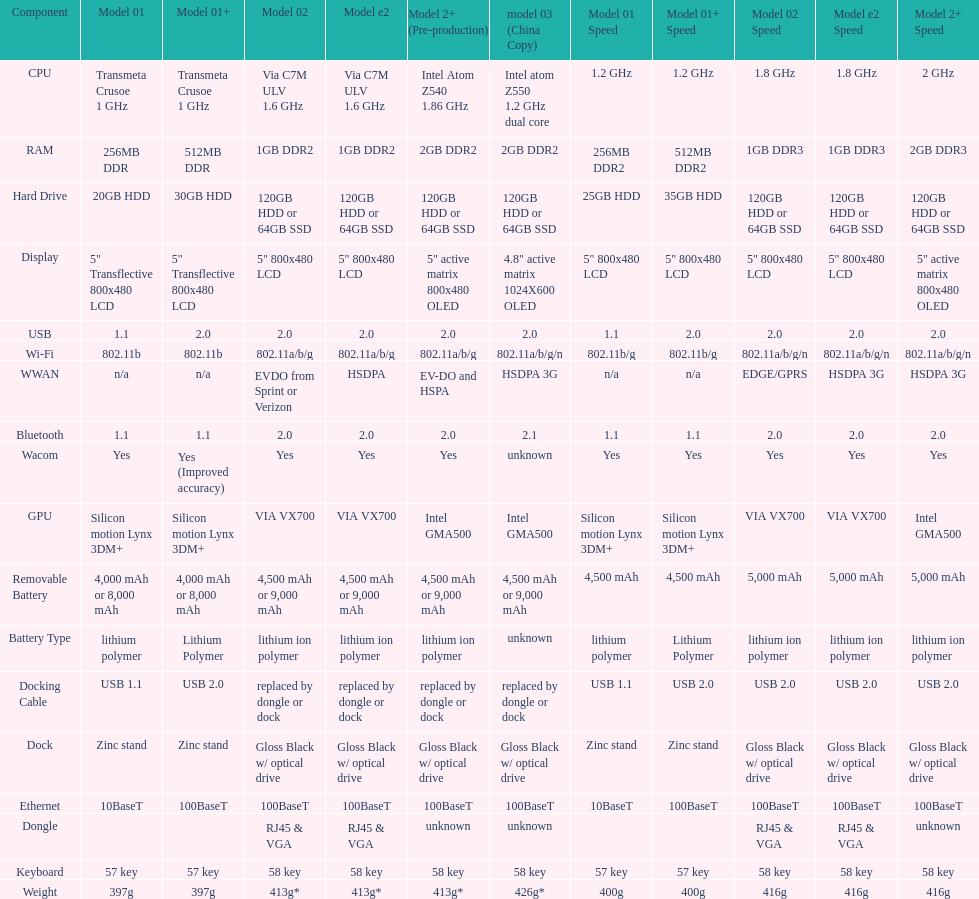Parse the full table. {'header': ['Component', 'Model 01', 'Model 01+', 'Model 02', 'Model e2', 'Model 2+ (Pre-production)', 'model 03 (China Copy)', 'Model 01 Speed', 'Model 01+ Speed', 'Model 02 Speed', 'Model e2 Speed', 'Model 2+ Speed'], 'rows': [['CPU', 'Transmeta Crusoe 1\xa0GHz', 'Transmeta Crusoe 1\xa0GHz', 'Via C7M ULV 1.6\xa0GHz', 'Via C7M ULV 1.6\xa0GHz', 'Intel Atom Z540 1.86\xa0GHz', 'Intel atom Z550 1.2\xa0GHz dual core', '1.2 GHz', '1.2 GHz', '1.8 GHz', '1.8 GHz', '2 GHz'], ['RAM', '256MB DDR', '512MB DDR', '1GB DDR2', '1GB DDR2', '2GB DDR2', '2GB DDR2', '256MB DDR2', '512MB DDR2', '1GB DDR3', '1GB DDR3', '2GB DDR3'], ['Hard Drive', '20GB HDD', '30GB HDD', '120GB HDD or 64GB SSD', '120GB HDD or 64GB SSD', '120GB HDD or 64GB SSD', '120GB HDD or 64GB SSD', '25GB HDD', '35GB HDD', '120GB HDD or 64GB SSD', '120GB HDD or 64GB SSD', '120GB HDD or 64GB SSD'], ['Display', '5" Transflective 800x480 LCD', '5" Transflective 800x480 LCD', '5" 800x480 LCD', '5" 800x480 LCD', '5" active matrix 800x480 OLED', '4.8" active matrix 1024X600 OLED', '5" 800x480 LCD', '5" 800x480 LCD', '5" 800x480 LCD', '5" 800x480 LCD', '5" active matrix 800x480 OLED'], ['USB', '1.1', '2.0', '2.0', '2.0', '2.0', '2.0', '1.1', '2.0', '2.0', '2.0', '2.0'], ['Wi-Fi', '802.11b', '802.11b', '802.11a/b/g', '802.11a/b/g', '802.11a/b/g', '802.11a/b/g/n', '802.11b/g', '802.11b/g', '802.11a/b/g/n', '802.11a/b/g/n', '802.11a/b/g/n'], ['WWAN', 'n/a', 'n/a', 'EVDO from Sprint or Verizon', 'HSDPA', 'EV-DO and HSPA', 'HSDPA 3G', 'n/a', 'n/a', 'EDGE/GPRS', 'HSDPA 3G', 'HSDPA 3G'], ['Bluetooth', '1.1', '1.1', '2.0', '2.0', '2.0', '2.1', '1.1', '1.1', '2.0', '2.0', '2.0'], ['Wacom', 'Yes', 'Yes (Improved accuracy)', 'Yes', 'Yes', 'Yes', 'unknown', 'Yes', 'Yes', 'Yes', 'Yes', 'Yes'], ['GPU', 'Silicon motion Lynx 3DM+', 'Silicon motion Lynx 3DM+', 'VIA VX700', 'VIA VX700', 'Intel GMA500', 'Intel GMA500', 'Silicon motion Lynx 3DM+', 'Silicon motion Lynx 3DM+', 'VIA VX700', 'VIA VX700', 'Intel GMA500'], ['Removable Battery', '4,000 mAh or 8,000 mAh', '4,000 mAh or 8,000 mAh', '4,500 mAh or 9,000 mAh', '4,500 mAh or 9,000 mAh', '4,500 mAh or 9,000 mAh', '4,500 mAh or 9,000 mAh', '4,500 mAh', '4,500 mAh', '5,000 mAh', '5,000 mAh', '5,000 mAh'], ['Battery Type', 'lithium polymer', 'Lithium Polymer', 'lithium ion polymer', 'lithium ion polymer', 'lithium ion polymer', 'unknown', 'lithium polymer', 'Lithium Polymer', 'lithium ion polymer', 'lithium ion polymer', 'lithium ion polymer'], ['Docking Cable', 'USB 1.1', 'USB 2.0', 'replaced by dongle or dock', 'replaced by dongle or dock', 'replaced by dongle or dock', 'replaced by dongle or dock', 'USB 1.1', 'USB 2.0', 'USB 2.0', 'USB 2.0', 'USB 2.0'], ['Dock', 'Zinc stand', 'Zinc stand', 'Gloss Black w/ optical drive', 'Gloss Black w/ optical drive', 'Gloss Black w/ optical drive', 'Gloss Black w/ optical drive', 'Zinc stand', 'Zinc stand', 'Gloss Black w/ optical drive', 'Gloss Black w/ optical drive', 'Gloss Black w/ optical drive'], ['Ethernet', '10BaseT', '100BaseT', '100BaseT', '100BaseT', '100BaseT', '100BaseT', '10BaseT', '100BaseT', '100BaseT', '100BaseT', '100BaseT'], ['Dongle', '', '', 'RJ45 & VGA', 'RJ45 & VGA', 'unknown', 'unknown', '', '', 'RJ45 & VGA', 'RJ45 & VGA', 'unknown'], ['Keyboard', '57 key', '57 key', '58 key', '58 key', '58 key', '58 key', '57 key', '57 key', '58 key', '58 key', '58 key'], ['Weight', '397g', '397g', '413g*', '413g*', '413g*', '426g*', '400g', '400g', '416g', '416g', '416g']]} The model 2 and the model 2e have what type of cpu? Via C7M ULV 1.6 GHz. 